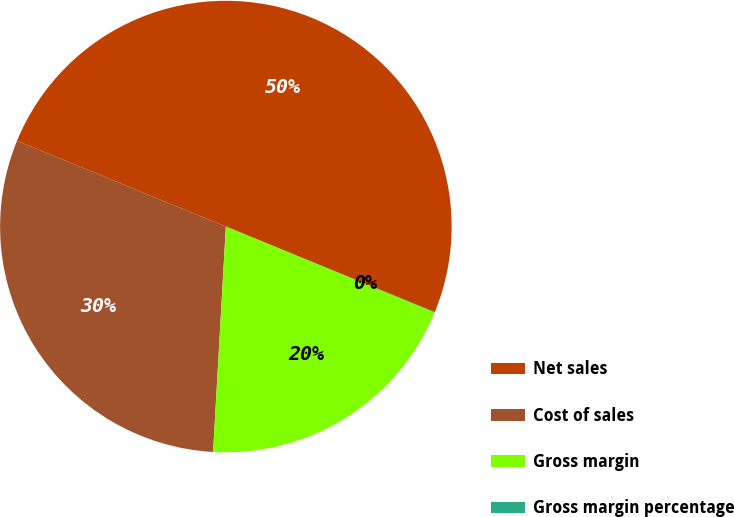Convert chart. <chart><loc_0><loc_0><loc_500><loc_500><pie_chart><fcel>Net sales<fcel>Cost of sales<fcel>Gross margin<fcel>Gross margin percentage<nl><fcel>49.98%<fcel>30.3%<fcel>19.68%<fcel>0.03%<nl></chart> 